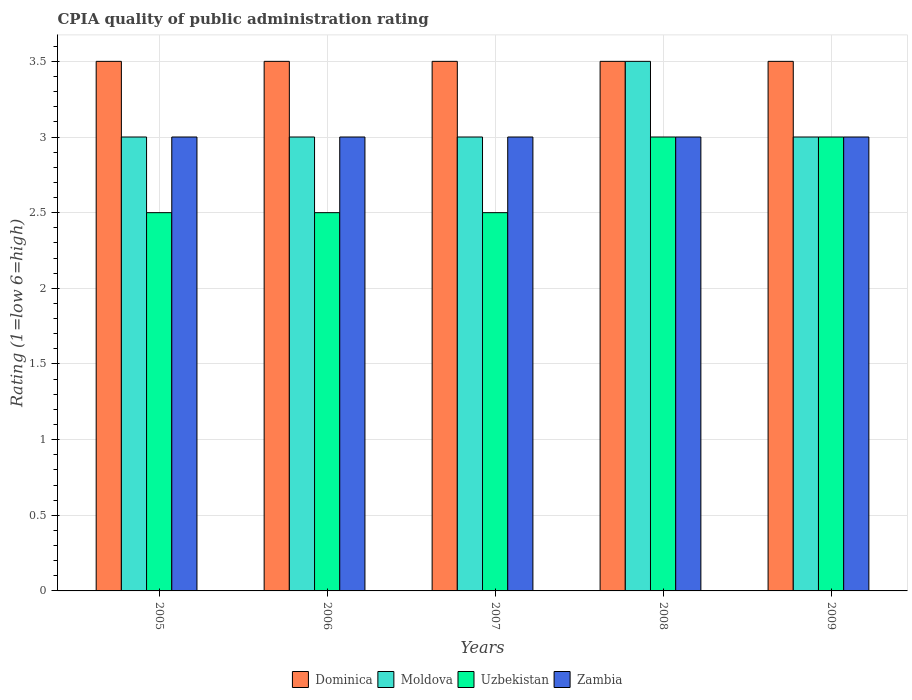How many different coloured bars are there?
Give a very brief answer. 4. Are the number of bars per tick equal to the number of legend labels?
Your response must be concise. Yes. How many bars are there on the 2nd tick from the left?
Your answer should be compact. 4. What is the CPIA rating in Zambia in 2007?
Offer a very short reply. 3. Across all years, what is the maximum CPIA rating in Zambia?
Make the answer very short. 3. Across all years, what is the minimum CPIA rating in Moldova?
Give a very brief answer. 3. In which year was the CPIA rating in Uzbekistan minimum?
Your answer should be very brief. 2005. What is the difference between the CPIA rating in Uzbekistan in 2006 and that in 2009?
Your answer should be compact. -0.5. What is the difference between the CPIA rating in Uzbekistan in 2008 and the CPIA rating in Moldova in 2007?
Keep it short and to the point. 0. Is the CPIA rating in Zambia in 2005 less than that in 2008?
Make the answer very short. No. Is the difference between the CPIA rating in Moldova in 2006 and 2009 greater than the difference between the CPIA rating in Zambia in 2006 and 2009?
Give a very brief answer. No. What is the difference between the highest and the second highest CPIA rating in Dominica?
Give a very brief answer. 0. What is the difference between the highest and the lowest CPIA rating in Moldova?
Give a very brief answer. 0.5. Is the sum of the CPIA rating in Zambia in 2005 and 2006 greater than the maximum CPIA rating in Uzbekistan across all years?
Provide a succinct answer. Yes. Is it the case that in every year, the sum of the CPIA rating in Dominica and CPIA rating in Zambia is greater than the sum of CPIA rating in Moldova and CPIA rating in Uzbekistan?
Make the answer very short. Yes. What does the 4th bar from the left in 2007 represents?
Give a very brief answer. Zambia. What does the 3rd bar from the right in 2005 represents?
Provide a succinct answer. Moldova. How many bars are there?
Make the answer very short. 20. Are all the bars in the graph horizontal?
Keep it short and to the point. No. How many years are there in the graph?
Ensure brevity in your answer.  5. Does the graph contain any zero values?
Offer a terse response. No. How many legend labels are there?
Keep it short and to the point. 4. How are the legend labels stacked?
Your answer should be compact. Horizontal. What is the title of the graph?
Your response must be concise. CPIA quality of public administration rating. What is the label or title of the Y-axis?
Your response must be concise. Rating (1=low 6=high). What is the Rating (1=low 6=high) in Dominica in 2005?
Offer a terse response. 3.5. What is the Rating (1=low 6=high) in Moldova in 2005?
Give a very brief answer. 3. What is the Rating (1=low 6=high) in Zambia in 2005?
Your answer should be very brief. 3. What is the Rating (1=low 6=high) in Zambia in 2006?
Offer a very short reply. 3. What is the Rating (1=low 6=high) in Uzbekistan in 2007?
Provide a succinct answer. 2.5. What is the Rating (1=low 6=high) of Zambia in 2008?
Your response must be concise. 3. What is the Rating (1=low 6=high) of Dominica in 2009?
Offer a terse response. 3.5. What is the Rating (1=low 6=high) of Uzbekistan in 2009?
Ensure brevity in your answer.  3. Across all years, what is the maximum Rating (1=low 6=high) of Dominica?
Make the answer very short. 3.5. Across all years, what is the maximum Rating (1=low 6=high) of Moldova?
Provide a succinct answer. 3.5. Across all years, what is the minimum Rating (1=low 6=high) of Moldova?
Offer a terse response. 3. What is the total Rating (1=low 6=high) in Dominica in the graph?
Ensure brevity in your answer.  17.5. What is the total Rating (1=low 6=high) in Moldova in the graph?
Ensure brevity in your answer.  15.5. What is the total Rating (1=low 6=high) of Uzbekistan in the graph?
Offer a very short reply. 13.5. What is the total Rating (1=low 6=high) in Zambia in the graph?
Provide a succinct answer. 15. What is the difference between the Rating (1=low 6=high) in Dominica in 2005 and that in 2006?
Your response must be concise. 0. What is the difference between the Rating (1=low 6=high) in Moldova in 2005 and that in 2006?
Keep it short and to the point. 0. What is the difference between the Rating (1=low 6=high) of Dominica in 2005 and that in 2007?
Provide a short and direct response. 0. What is the difference between the Rating (1=low 6=high) of Uzbekistan in 2005 and that in 2007?
Your answer should be very brief. 0. What is the difference between the Rating (1=low 6=high) in Zambia in 2005 and that in 2007?
Your answer should be very brief. 0. What is the difference between the Rating (1=low 6=high) in Uzbekistan in 2005 and that in 2008?
Your answer should be compact. -0.5. What is the difference between the Rating (1=low 6=high) in Zambia in 2005 and that in 2008?
Your answer should be very brief. 0. What is the difference between the Rating (1=low 6=high) of Zambia in 2005 and that in 2009?
Provide a short and direct response. 0. What is the difference between the Rating (1=low 6=high) of Uzbekistan in 2006 and that in 2007?
Give a very brief answer. 0. What is the difference between the Rating (1=low 6=high) in Zambia in 2006 and that in 2007?
Offer a terse response. 0. What is the difference between the Rating (1=low 6=high) of Dominica in 2006 and that in 2008?
Your answer should be very brief. 0. What is the difference between the Rating (1=low 6=high) of Moldova in 2006 and that in 2008?
Your response must be concise. -0.5. What is the difference between the Rating (1=low 6=high) of Uzbekistan in 2006 and that in 2008?
Offer a terse response. -0.5. What is the difference between the Rating (1=low 6=high) in Zambia in 2006 and that in 2008?
Your answer should be compact. 0. What is the difference between the Rating (1=low 6=high) of Moldova in 2006 and that in 2009?
Your answer should be very brief. 0. What is the difference between the Rating (1=low 6=high) in Dominica in 2007 and that in 2008?
Your answer should be compact. 0. What is the difference between the Rating (1=low 6=high) of Zambia in 2007 and that in 2008?
Offer a very short reply. 0. What is the difference between the Rating (1=low 6=high) in Dominica in 2007 and that in 2009?
Your answer should be compact. 0. What is the difference between the Rating (1=low 6=high) of Moldova in 2007 and that in 2009?
Offer a terse response. 0. What is the difference between the Rating (1=low 6=high) of Zambia in 2007 and that in 2009?
Your answer should be very brief. 0. What is the difference between the Rating (1=low 6=high) in Dominica in 2008 and that in 2009?
Your answer should be very brief. 0. What is the difference between the Rating (1=low 6=high) in Moldova in 2008 and that in 2009?
Your response must be concise. 0.5. What is the difference between the Rating (1=low 6=high) in Zambia in 2008 and that in 2009?
Your answer should be compact. 0. What is the difference between the Rating (1=low 6=high) of Dominica in 2005 and the Rating (1=low 6=high) of Moldova in 2006?
Offer a very short reply. 0.5. What is the difference between the Rating (1=low 6=high) in Dominica in 2005 and the Rating (1=low 6=high) in Uzbekistan in 2006?
Provide a short and direct response. 1. What is the difference between the Rating (1=low 6=high) of Dominica in 2005 and the Rating (1=low 6=high) of Zambia in 2006?
Keep it short and to the point. 0.5. What is the difference between the Rating (1=low 6=high) in Moldova in 2005 and the Rating (1=low 6=high) in Uzbekistan in 2006?
Your response must be concise. 0.5. What is the difference between the Rating (1=low 6=high) in Uzbekistan in 2005 and the Rating (1=low 6=high) in Zambia in 2006?
Provide a succinct answer. -0.5. What is the difference between the Rating (1=low 6=high) in Dominica in 2005 and the Rating (1=low 6=high) in Uzbekistan in 2007?
Provide a succinct answer. 1. What is the difference between the Rating (1=low 6=high) in Dominica in 2005 and the Rating (1=low 6=high) in Zambia in 2007?
Offer a very short reply. 0.5. What is the difference between the Rating (1=low 6=high) in Moldova in 2005 and the Rating (1=low 6=high) in Uzbekistan in 2007?
Give a very brief answer. 0.5. What is the difference between the Rating (1=low 6=high) in Dominica in 2005 and the Rating (1=low 6=high) in Uzbekistan in 2008?
Your answer should be very brief. 0.5. What is the difference between the Rating (1=low 6=high) of Dominica in 2005 and the Rating (1=low 6=high) of Zambia in 2008?
Offer a very short reply. 0.5. What is the difference between the Rating (1=low 6=high) in Moldova in 2005 and the Rating (1=low 6=high) in Uzbekistan in 2008?
Give a very brief answer. 0. What is the difference between the Rating (1=low 6=high) in Moldova in 2005 and the Rating (1=low 6=high) in Zambia in 2008?
Provide a short and direct response. 0. What is the difference between the Rating (1=low 6=high) in Uzbekistan in 2005 and the Rating (1=low 6=high) in Zambia in 2008?
Provide a succinct answer. -0.5. What is the difference between the Rating (1=low 6=high) of Dominica in 2005 and the Rating (1=low 6=high) of Moldova in 2009?
Ensure brevity in your answer.  0.5. What is the difference between the Rating (1=low 6=high) in Dominica in 2005 and the Rating (1=low 6=high) in Uzbekistan in 2009?
Offer a very short reply. 0.5. What is the difference between the Rating (1=low 6=high) of Dominica in 2005 and the Rating (1=low 6=high) of Zambia in 2009?
Your answer should be very brief. 0.5. What is the difference between the Rating (1=low 6=high) of Moldova in 2005 and the Rating (1=low 6=high) of Zambia in 2009?
Your answer should be compact. 0. What is the difference between the Rating (1=low 6=high) in Dominica in 2006 and the Rating (1=low 6=high) in Uzbekistan in 2007?
Offer a very short reply. 1. What is the difference between the Rating (1=low 6=high) in Uzbekistan in 2006 and the Rating (1=low 6=high) in Zambia in 2007?
Provide a short and direct response. -0.5. What is the difference between the Rating (1=low 6=high) in Dominica in 2006 and the Rating (1=low 6=high) in Uzbekistan in 2008?
Provide a succinct answer. 0.5. What is the difference between the Rating (1=low 6=high) in Moldova in 2006 and the Rating (1=low 6=high) in Uzbekistan in 2008?
Offer a very short reply. 0. What is the difference between the Rating (1=low 6=high) of Uzbekistan in 2006 and the Rating (1=low 6=high) of Zambia in 2008?
Your response must be concise. -0.5. What is the difference between the Rating (1=low 6=high) of Moldova in 2006 and the Rating (1=low 6=high) of Zambia in 2009?
Keep it short and to the point. 0. What is the difference between the Rating (1=low 6=high) of Dominica in 2007 and the Rating (1=low 6=high) of Moldova in 2008?
Make the answer very short. 0. What is the difference between the Rating (1=low 6=high) in Dominica in 2007 and the Rating (1=low 6=high) in Uzbekistan in 2008?
Offer a very short reply. 0.5. What is the difference between the Rating (1=low 6=high) in Dominica in 2007 and the Rating (1=low 6=high) in Zambia in 2009?
Offer a terse response. 0.5. What is the difference between the Rating (1=low 6=high) in Moldova in 2007 and the Rating (1=low 6=high) in Zambia in 2009?
Keep it short and to the point. 0. What is the difference between the Rating (1=low 6=high) in Uzbekistan in 2007 and the Rating (1=low 6=high) in Zambia in 2009?
Keep it short and to the point. -0.5. What is the difference between the Rating (1=low 6=high) of Dominica in 2008 and the Rating (1=low 6=high) of Uzbekistan in 2009?
Your response must be concise. 0.5. What is the difference between the Rating (1=low 6=high) of Dominica in 2008 and the Rating (1=low 6=high) of Zambia in 2009?
Your response must be concise. 0.5. What is the difference between the Rating (1=low 6=high) of Moldova in 2008 and the Rating (1=low 6=high) of Uzbekistan in 2009?
Make the answer very short. 0.5. What is the difference between the Rating (1=low 6=high) in Moldova in 2008 and the Rating (1=low 6=high) in Zambia in 2009?
Keep it short and to the point. 0.5. What is the average Rating (1=low 6=high) in Moldova per year?
Your response must be concise. 3.1. What is the average Rating (1=low 6=high) in Zambia per year?
Offer a very short reply. 3. In the year 2005, what is the difference between the Rating (1=low 6=high) of Dominica and Rating (1=low 6=high) of Uzbekistan?
Provide a succinct answer. 1. In the year 2005, what is the difference between the Rating (1=low 6=high) in Dominica and Rating (1=low 6=high) in Zambia?
Offer a very short reply. 0.5. In the year 2006, what is the difference between the Rating (1=low 6=high) in Dominica and Rating (1=low 6=high) in Moldova?
Provide a succinct answer. 0.5. In the year 2006, what is the difference between the Rating (1=low 6=high) of Dominica and Rating (1=low 6=high) of Uzbekistan?
Your response must be concise. 1. In the year 2006, what is the difference between the Rating (1=low 6=high) of Dominica and Rating (1=low 6=high) of Zambia?
Provide a succinct answer. 0.5. In the year 2006, what is the difference between the Rating (1=low 6=high) of Moldova and Rating (1=low 6=high) of Uzbekistan?
Provide a short and direct response. 0.5. In the year 2007, what is the difference between the Rating (1=low 6=high) in Dominica and Rating (1=low 6=high) in Moldova?
Provide a short and direct response. 0.5. In the year 2007, what is the difference between the Rating (1=low 6=high) of Dominica and Rating (1=low 6=high) of Zambia?
Provide a short and direct response. 0.5. In the year 2007, what is the difference between the Rating (1=low 6=high) of Uzbekistan and Rating (1=low 6=high) of Zambia?
Offer a terse response. -0.5. In the year 2008, what is the difference between the Rating (1=low 6=high) in Dominica and Rating (1=low 6=high) in Uzbekistan?
Offer a very short reply. 0.5. In the year 2008, what is the difference between the Rating (1=low 6=high) in Uzbekistan and Rating (1=low 6=high) in Zambia?
Provide a short and direct response. 0. In the year 2009, what is the difference between the Rating (1=low 6=high) of Dominica and Rating (1=low 6=high) of Zambia?
Keep it short and to the point. 0.5. In the year 2009, what is the difference between the Rating (1=low 6=high) in Moldova and Rating (1=low 6=high) in Uzbekistan?
Keep it short and to the point. 0. In the year 2009, what is the difference between the Rating (1=low 6=high) of Moldova and Rating (1=low 6=high) of Zambia?
Give a very brief answer. 0. What is the ratio of the Rating (1=low 6=high) in Dominica in 2005 to that in 2006?
Provide a short and direct response. 1. What is the ratio of the Rating (1=low 6=high) in Zambia in 2005 to that in 2006?
Your response must be concise. 1. What is the ratio of the Rating (1=low 6=high) in Dominica in 2005 to that in 2007?
Provide a succinct answer. 1. What is the ratio of the Rating (1=low 6=high) in Dominica in 2005 to that in 2008?
Your answer should be very brief. 1. What is the ratio of the Rating (1=low 6=high) in Uzbekistan in 2005 to that in 2008?
Keep it short and to the point. 0.83. What is the ratio of the Rating (1=low 6=high) of Zambia in 2005 to that in 2008?
Offer a very short reply. 1. What is the ratio of the Rating (1=low 6=high) in Dominica in 2005 to that in 2009?
Provide a succinct answer. 1. What is the ratio of the Rating (1=low 6=high) in Moldova in 2005 to that in 2009?
Ensure brevity in your answer.  1. What is the ratio of the Rating (1=low 6=high) in Zambia in 2005 to that in 2009?
Offer a terse response. 1. What is the ratio of the Rating (1=low 6=high) in Moldova in 2006 to that in 2007?
Make the answer very short. 1. What is the ratio of the Rating (1=low 6=high) of Zambia in 2006 to that in 2007?
Your answer should be very brief. 1. What is the ratio of the Rating (1=low 6=high) of Moldova in 2006 to that in 2008?
Give a very brief answer. 0.86. What is the ratio of the Rating (1=low 6=high) of Uzbekistan in 2006 to that in 2008?
Give a very brief answer. 0.83. What is the ratio of the Rating (1=low 6=high) in Zambia in 2006 to that in 2008?
Make the answer very short. 1. What is the ratio of the Rating (1=low 6=high) of Dominica in 2006 to that in 2009?
Keep it short and to the point. 1. What is the ratio of the Rating (1=low 6=high) of Zambia in 2006 to that in 2009?
Provide a short and direct response. 1. What is the ratio of the Rating (1=low 6=high) in Dominica in 2007 to that in 2008?
Provide a succinct answer. 1. What is the ratio of the Rating (1=low 6=high) of Moldova in 2007 to that in 2008?
Ensure brevity in your answer.  0.86. What is the ratio of the Rating (1=low 6=high) of Uzbekistan in 2007 to that in 2008?
Give a very brief answer. 0.83. What is the ratio of the Rating (1=low 6=high) in Zambia in 2007 to that in 2009?
Your answer should be compact. 1. What is the ratio of the Rating (1=low 6=high) of Moldova in 2008 to that in 2009?
Provide a succinct answer. 1.17. What is the ratio of the Rating (1=low 6=high) in Zambia in 2008 to that in 2009?
Provide a short and direct response. 1. What is the difference between the highest and the second highest Rating (1=low 6=high) in Dominica?
Your answer should be compact. 0. What is the difference between the highest and the second highest Rating (1=low 6=high) in Moldova?
Provide a short and direct response. 0.5. What is the difference between the highest and the second highest Rating (1=low 6=high) in Uzbekistan?
Your answer should be compact. 0. What is the difference between the highest and the lowest Rating (1=low 6=high) of Moldova?
Give a very brief answer. 0.5. What is the difference between the highest and the lowest Rating (1=low 6=high) of Uzbekistan?
Your answer should be compact. 0.5. 